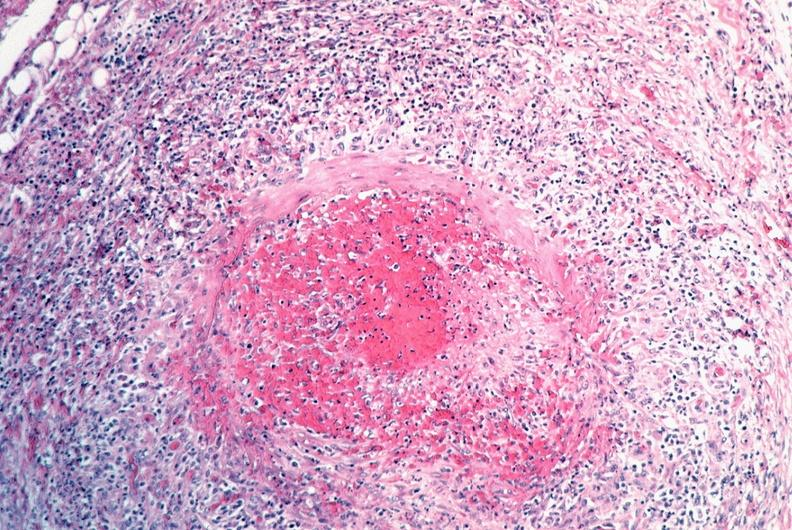s cardiovascular present?
Answer the question using a single word or phrase. Yes 